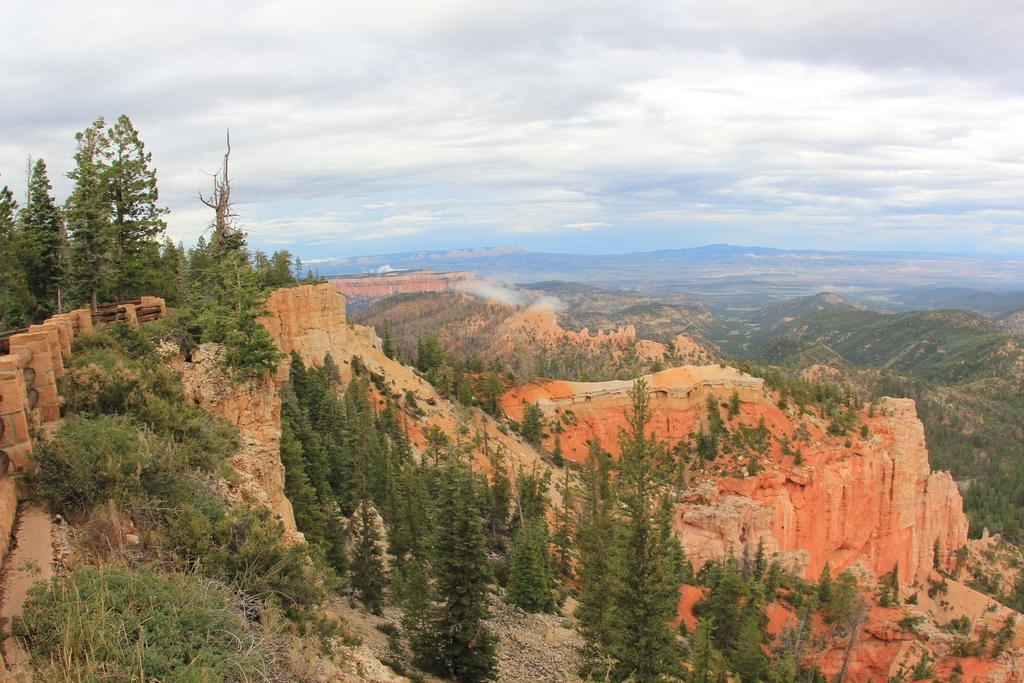What type of natural landscape is depicted in the image? The image features mountains. What other elements can be seen in the image? There are rocks, plants, and trees in the image. How would you describe the sky in the image? The sky is cloudy in the image. What type of button can be seen on the corn in the image? There is no button or corn present in the image; it features mountains, rocks, plants, trees, and a cloudy sky. 